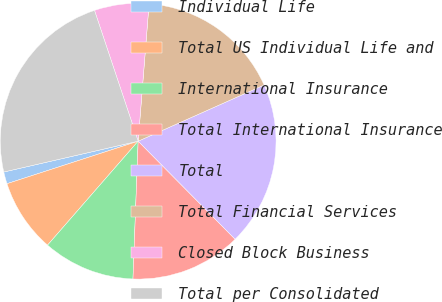Convert chart. <chart><loc_0><loc_0><loc_500><loc_500><pie_chart><fcel>Individual Life<fcel>Total US Individual Life and<fcel>International Insurance<fcel>Total International Insurance<fcel>Total<fcel>Total Financial Services<fcel>Closed Block Business<fcel>Total per Consolidated<nl><fcel>1.4%<fcel>8.6%<fcel>10.81%<fcel>13.01%<fcel>19.27%<fcel>17.06%<fcel>6.39%<fcel>23.46%<nl></chart> 